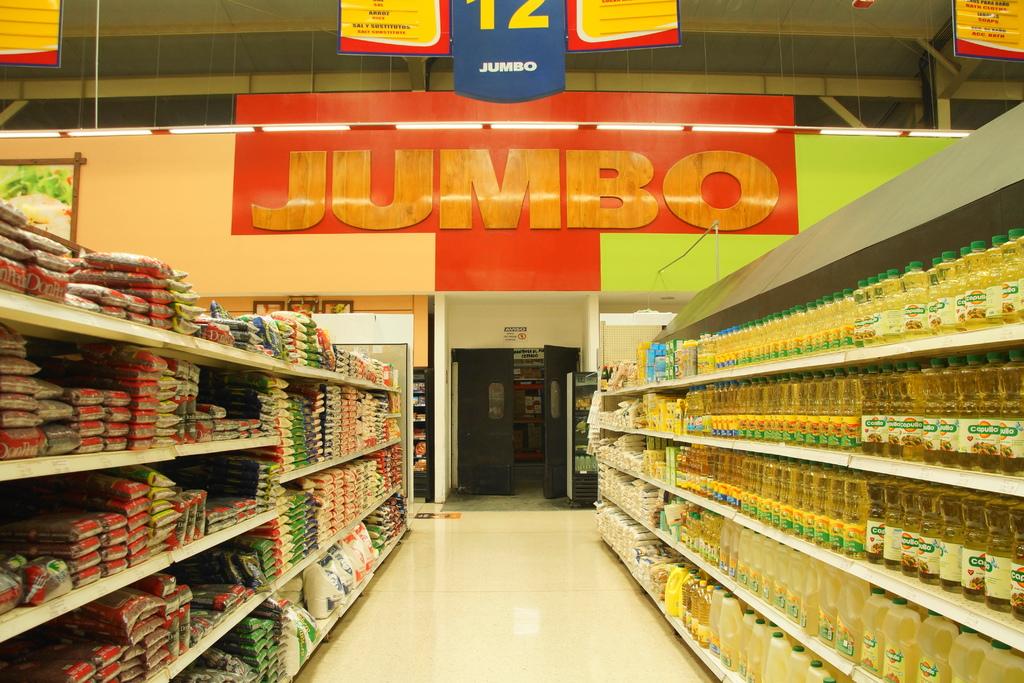What large sign is shown on the wall?
Offer a very short reply. Jumbo. What aisle number is this?
Your response must be concise. 12. 